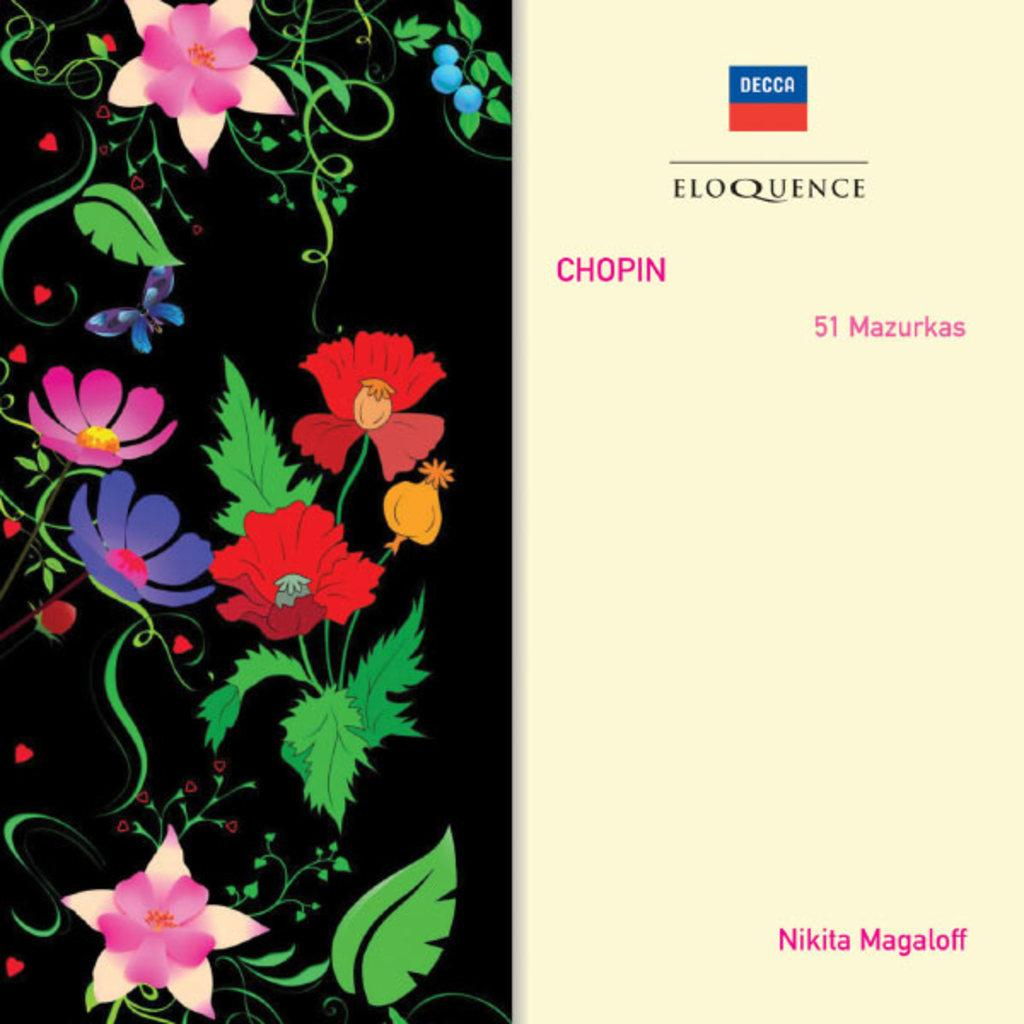What is present on the image? There is a poster in the image. What can be seen on the left side of the poster? There are flowers on the left side of the poster. What is featured on the right side of the poster? There is some script on the right side of the poster. What type of apparel is the rock wearing in the image? There is no rock or apparel present in the image; it features a poster with flowers and script. 